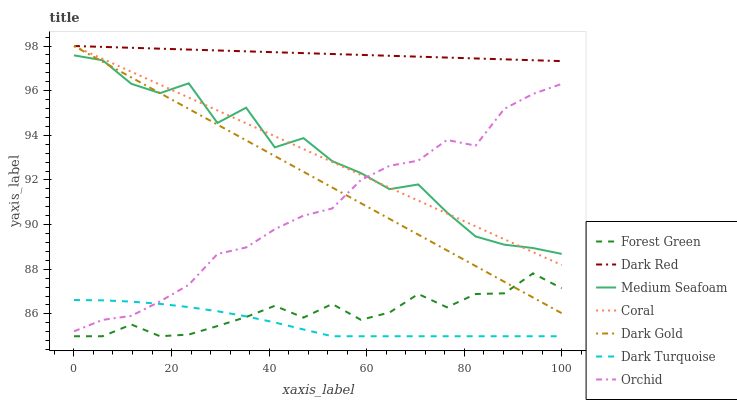Does Dark Turquoise have the minimum area under the curve?
Answer yes or no. Yes. Does Dark Red have the maximum area under the curve?
Answer yes or no. Yes. Does Coral have the minimum area under the curve?
Answer yes or no. No. Does Coral have the maximum area under the curve?
Answer yes or no. No. Is Dark Red the smoothest?
Answer yes or no. Yes. Is Medium Seafoam the roughest?
Answer yes or no. Yes. Is Coral the smoothest?
Answer yes or no. No. Is Coral the roughest?
Answer yes or no. No. Does Coral have the lowest value?
Answer yes or no. No. Does Coral have the highest value?
Answer yes or no. Yes. Does Forest Green have the highest value?
Answer yes or no. No. Is Orchid less than Dark Red?
Answer yes or no. Yes. Is Coral greater than Forest Green?
Answer yes or no. Yes. Does Orchid intersect Dark Red?
Answer yes or no. No. 